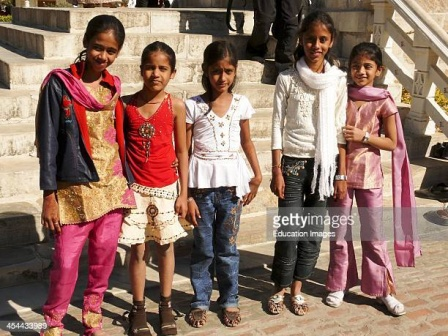If this scene were part of a story, what might be happening just outside the frame? Just outside the frame, the girls' families and friends might be gathered, enjoying a celebration or a community event. Perhaps there's music playing, and the air is filled with the sounds of laughter and conversation. Vendors might be selling food and treats, adding to the festive atmosphere. Nearby, younger children could be playing games, while adults engage in lively discussions. This vibrant and spirited backdrop serves as the perfect setting for the girls' cheerful moment on the stone stairs. Imagine a magical twist to this scene. What could be happening? In a magical twist, the stone stairs where the girls stand might be part of an ancient enchanted structure. As they pose for the picture, the stairs begin to glow softly, revealing hidden symbols etched into the stone. The air shimmers with a golden light, and suddenly, the girls find themselves in a mystical garden filled with exotic, luminous flowers and fluttering, iridescent butterflies. They are greeted by a friendly guide who reveals that they have been chosen to embark on an extraordinary quest to find a legendary artifact that can restore harmony to their town. The girls, captivated and excited by this unexpected adventure, set off on their magical journey, each using their unique strengths to overcome challenges and uncover the secrets of the enchanted garden.  Suppose this image was captured during a significant festival. Describe the festival and its activities. This image might have been taken during a vibrant cultural festival celebrating heritage and traditions. The festival could involve colorful parades where participants dress in traditional attire, much like the girls in the image. There might be dance performances showcasing folk and classical styles, accompanied by live music featuring traditional instruments. Stalls could be set up, selling handcrafted goods, traditional foods, and sweets. Workshops teaching traditional crafts, storytelling sessions sharing local myths and legends, and competitions in music and dance could also be part of the festivities. The atmosphere is lively, filled with the sounds of joy and celebration, creating an unforgettable experience for all attendees. 